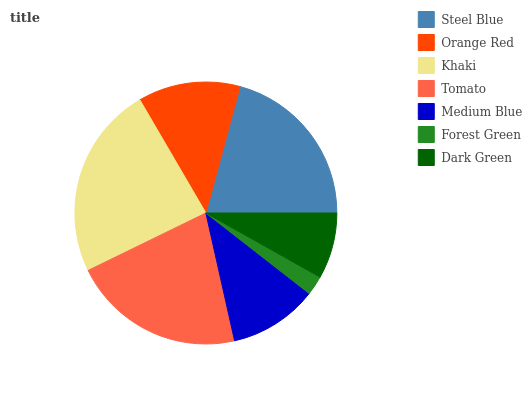Is Forest Green the minimum?
Answer yes or no. Yes. Is Khaki the maximum?
Answer yes or no. Yes. Is Orange Red the minimum?
Answer yes or no. No. Is Orange Red the maximum?
Answer yes or no. No. Is Steel Blue greater than Orange Red?
Answer yes or no. Yes. Is Orange Red less than Steel Blue?
Answer yes or no. Yes. Is Orange Red greater than Steel Blue?
Answer yes or no. No. Is Steel Blue less than Orange Red?
Answer yes or no. No. Is Orange Red the high median?
Answer yes or no. Yes. Is Orange Red the low median?
Answer yes or no. Yes. Is Dark Green the high median?
Answer yes or no. No. Is Medium Blue the low median?
Answer yes or no. No. 